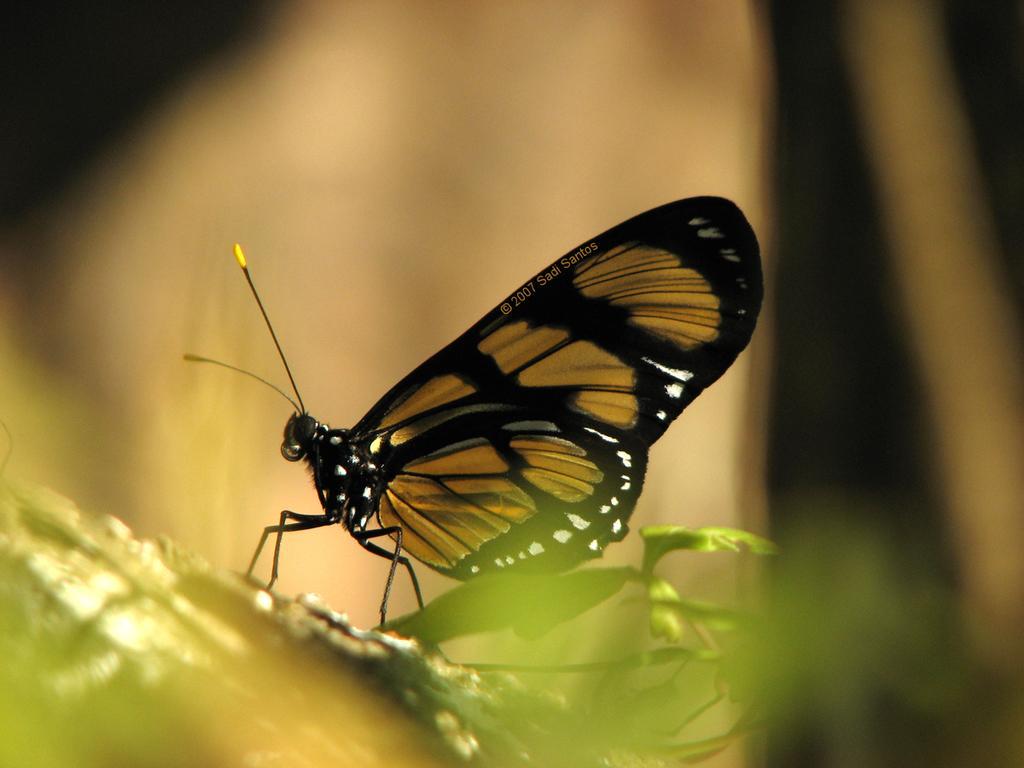Please provide a concise description of this image. It is a beautiful butterfly which is in brown and black color. 